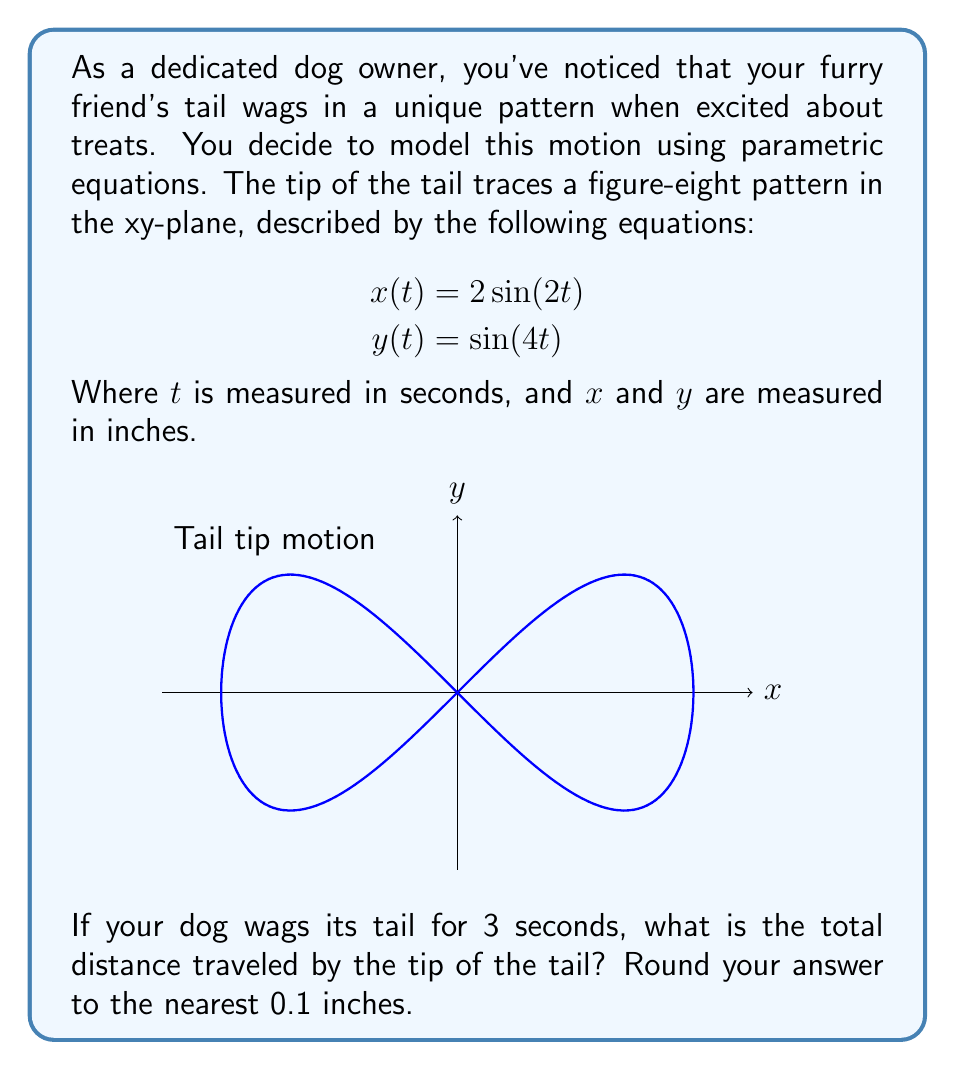Can you answer this question? To solve this problem, we'll follow these steps:

1) The distance traveled is given by the arc length formula for parametric equations:

   $$L = \int_a^b \sqrt{\left(\frac{dx}{dt}\right)^2 + \left(\frac{dy}{dt}\right)^2} dt$$

2) First, we need to find $\frac{dx}{dt}$ and $\frac{dy}{dt}$:
   
   $$\frac{dx}{dt} = 4\cos(2t)$$
   $$\frac{dy}{dt} = 4\cos(4t)$$

3) Now we can set up the integral:

   $$L = \int_0^3 \sqrt{(4\cos(2t))^2 + (4\cos(4t))^2} dt$$

4) Simplify under the square root:

   $$L = \int_0^3 \sqrt{16\cos^2(2t) + 16\cos^2(4t)} dt$$

5) Factor out the common factor:

   $$L = 4\int_0^3 \sqrt{\cos^2(2t) + \cos^2(4t)} dt$$

6) This integral cannot be solved analytically, so we need to use numerical integration methods. Using a computer algebra system or numerical integration calculator, we get:

   $$L \approx 21.2658$$

7) Rounding to the nearest 0.1 inches:

   $$L \approx 21.3 \text{ inches}$$
Answer: 21.3 inches 